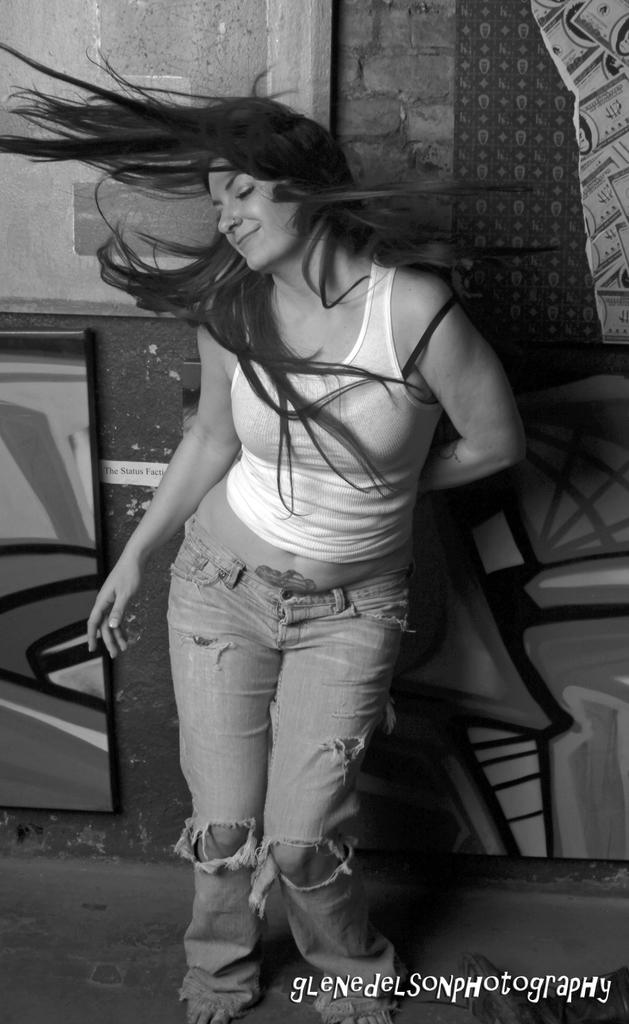What is the color scheme of the image? The image is black and white. Who or what is at the front of the image? There is a person standing at the front of the image. What surface is the person standing on? The person is standing on the floor. What is located at the back of the image? There is a wall at the back of the image. What type of magic is being performed by the person in the image? There is no indication of magic or any magical activity in the image. 